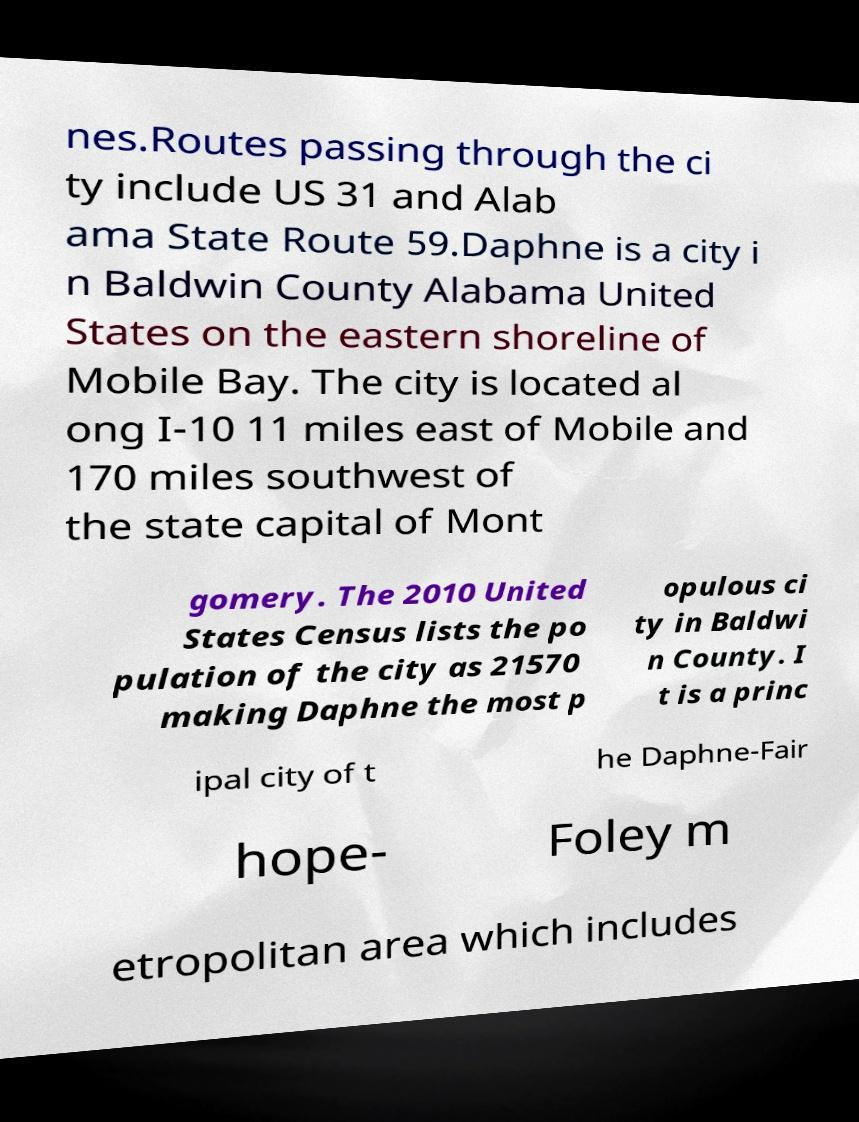Could you extract and type out the text from this image? nes.Routes passing through the ci ty include US 31 and Alab ama State Route 59.Daphne is a city i n Baldwin County Alabama United States on the eastern shoreline of Mobile Bay. The city is located al ong I-10 11 miles east of Mobile and 170 miles southwest of the state capital of Mont gomery. The 2010 United States Census lists the po pulation of the city as 21570 making Daphne the most p opulous ci ty in Baldwi n County. I t is a princ ipal city of t he Daphne-Fair hope- Foley m etropolitan area which includes 